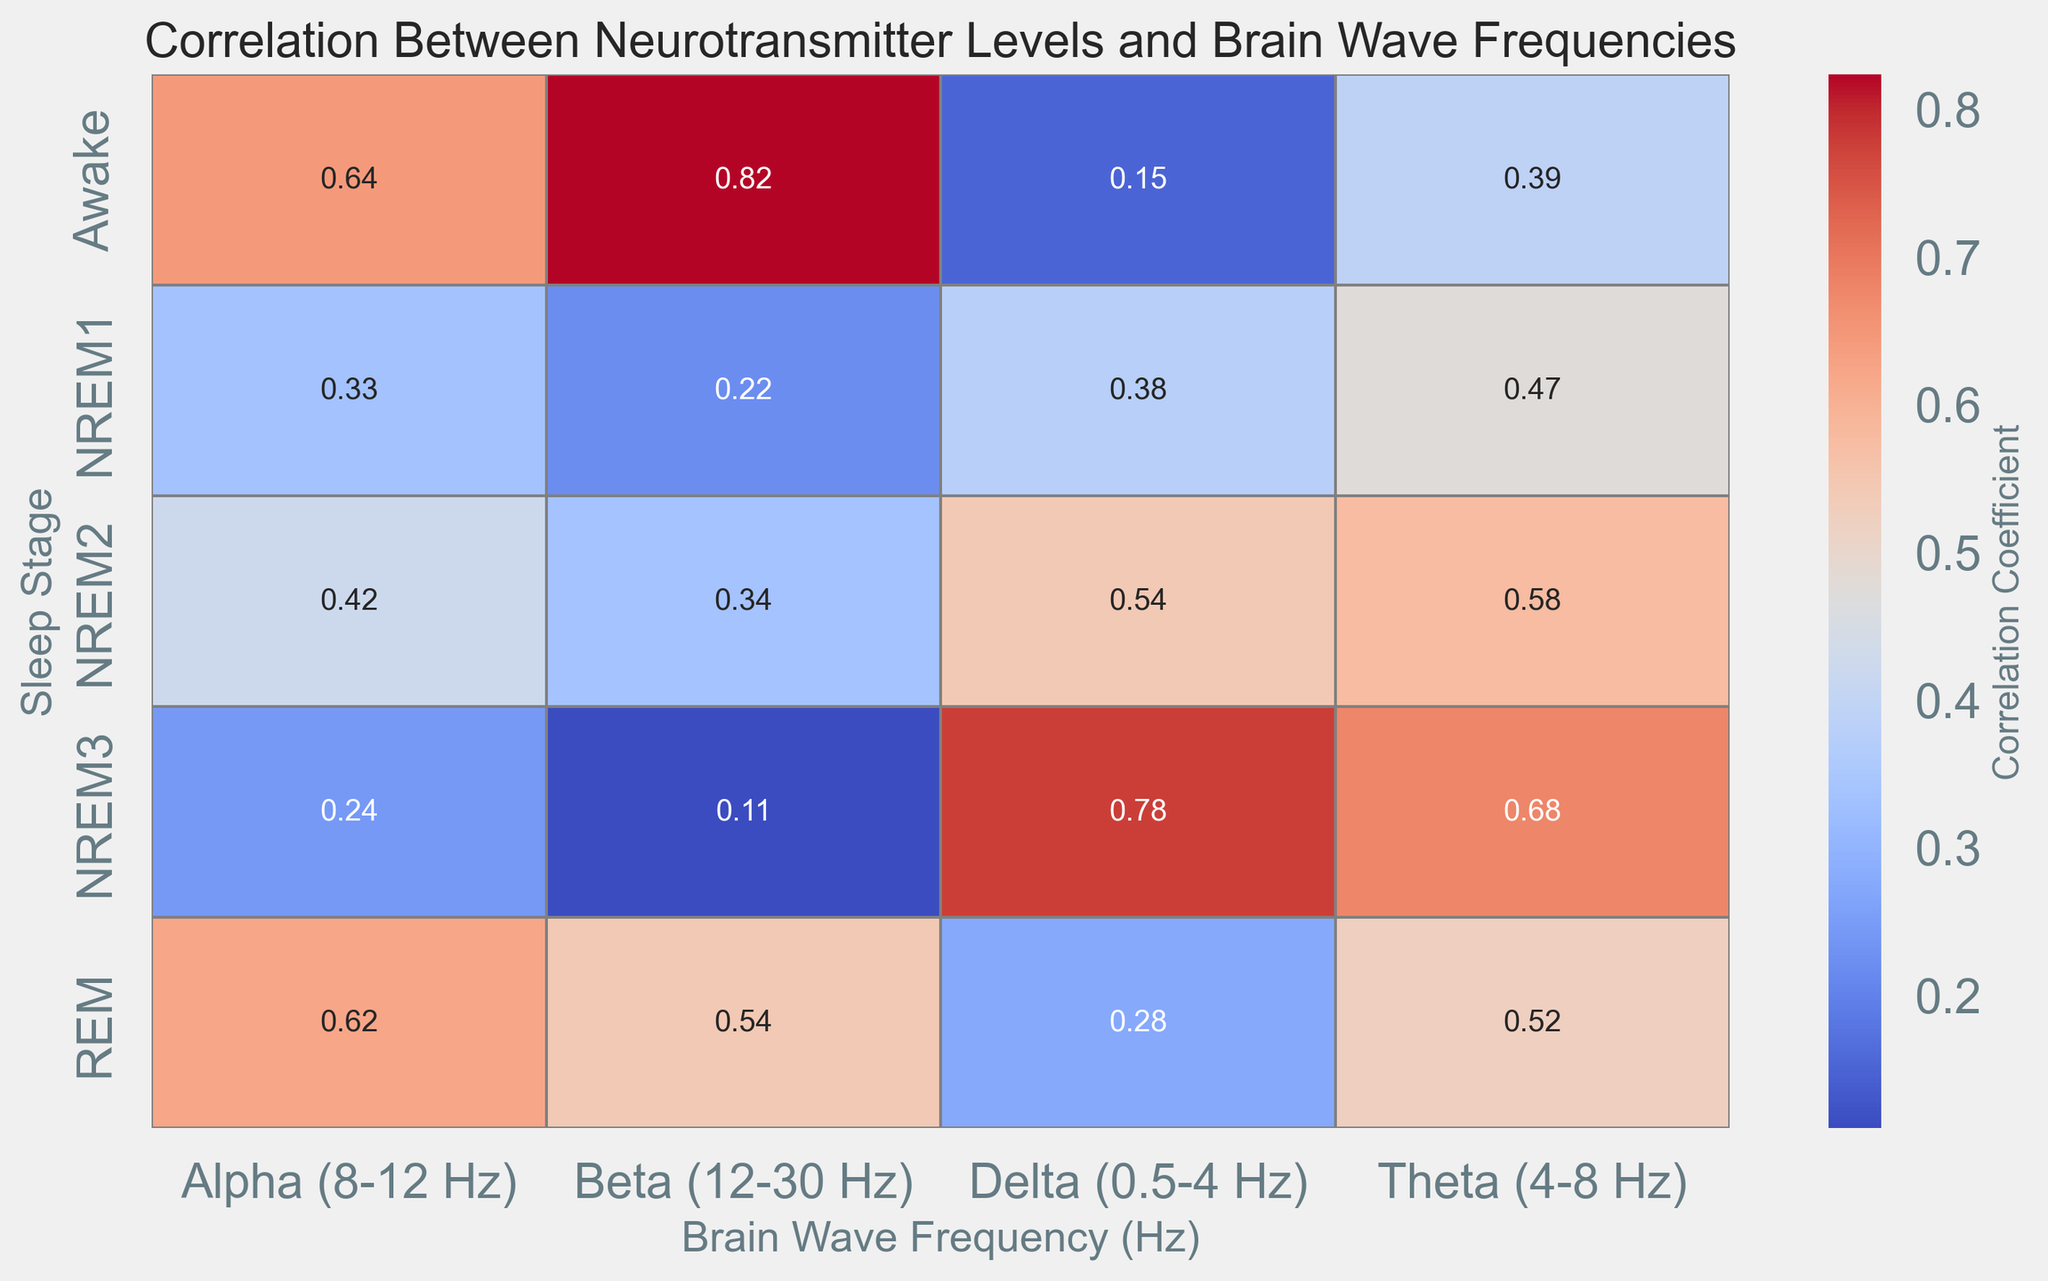What is the correlation coefficient between Delta waves and neurotransmitter levels during NREM3 sleep? To find the correlation coefficient between Delta waves and neurotransmitter levels during NREM3 sleep, locate the cell where the 'Delta (0.5-4 Hz)' column intersects with the 'NREM3' row in the heatmap.
Answer: 0.78 Which sleep stage has the highest average correlation coefficient with neurotransmitter levels across all brain wave frequencies? Calculate the average correlation coefficient for each sleep stage by summing the values across all brain wave frequencies and dividing by the number of frequencies. The highest average value will indicate the sleep stage with the strongest overall correlation. For NREM3: (0.78 + 0.68 + 0.28 + 0.11) / 4 = 0.463. For all others, the averages will be lower.
Answer: NREM3 During which sleep stage do Alpha waves have their highest correlation with neurotransmitter levels? Find the cell in the 'Alpha (8-12 Hz)' column that has the highest value by comparing the values across all rows representing different sleep stages.
Answer: REM How does the correlation between Beta waves and neurotransmitter levels in the Awake stage compare to that in the REM stage? Locate the 'Beta (12-30 Hz)' column, then compare the values for the 'Awake' and 'REM' rows. In the Awake stage, it is 0.82, while in the REM stage, it is 0.5.
Answer: Higher in the Awake stage Is there a sleep stage where all brain wave frequencies have a correlation coefficient above 0.6 with neurotransmitter levels? Check each row to see if all the correlation values in that row are above 0.6. Only NREM3 has Delta and Theta correlations above 0.6, and none of the other sleep stages meets this criterion across all brain wave frequencies.
Answer: No What is the difference in the correlation coefficient between Delta waves and Beta waves during NREM2 sleep? Find the 'NREM2' row and subtract the correlation coefficient of Beta waves from the correlation coefficient of Delta waves: 0.53 - 0.33 = 0.20.
Answer: 0.20 What is the median correlation coefficient value for the Theta wave across all sleep stages? Collect the correlation values for the Theta wave from all sleep stages and find the middle value when they are ordered from smallest to largest: (0.42, 0.45, 0.47, 0.52, 0.55, 0.58, 0.6, 0.65, 0.68, 0.7) - median is (0.55+0.58)/2 = 0.565.
Answer: 0.565 Which sleep stage has the smallest correlation with Beta wave frequencies, and what is that correlation coefficient? Locate the 'Beta (12-30 Hz)' column, compare values for all sleep stages, and identify the smallest value. The smallest value in the 'Beta (12-30 Hz)' column is 0.1 in the NREM3 stage.
Answer: NREM3, 0.1 